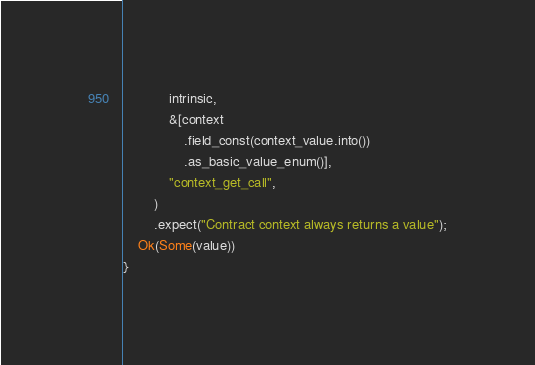Convert code to text. <code><loc_0><loc_0><loc_500><loc_500><_Rust_>            intrinsic,
            &[context
                .field_const(context_value.into())
                .as_basic_value_enum()],
            "context_get_call",
        )
        .expect("Contract context always returns a value");
    Ok(Some(value))
}
</code> 